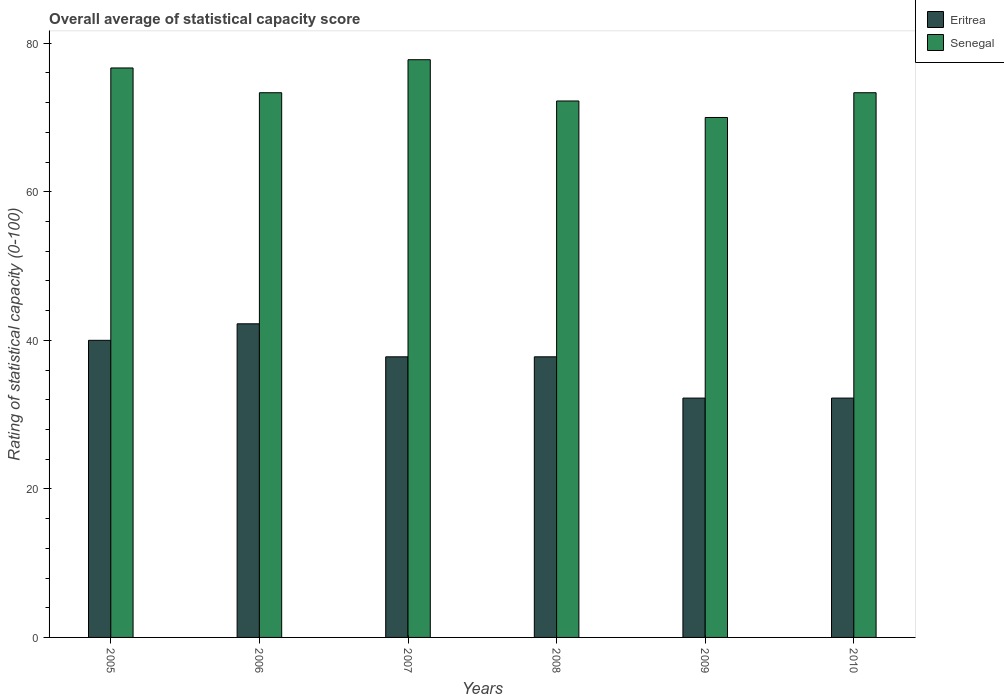How many different coloured bars are there?
Keep it short and to the point. 2. Are the number of bars per tick equal to the number of legend labels?
Give a very brief answer. Yes. How many bars are there on the 4th tick from the right?
Your answer should be very brief. 2. What is the label of the 5th group of bars from the left?
Offer a terse response. 2009. In how many cases, is the number of bars for a given year not equal to the number of legend labels?
Offer a terse response. 0. What is the rating of statistical capacity in Eritrea in 2009?
Offer a terse response. 32.22. Across all years, what is the maximum rating of statistical capacity in Eritrea?
Offer a terse response. 42.22. Across all years, what is the minimum rating of statistical capacity in Eritrea?
Ensure brevity in your answer.  32.22. In which year was the rating of statistical capacity in Senegal minimum?
Offer a terse response. 2009. What is the total rating of statistical capacity in Eritrea in the graph?
Make the answer very short. 222.22. What is the difference between the rating of statistical capacity in Senegal in 2008 and that in 2009?
Provide a short and direct response. 2.22. What is the difference between the rating of statistical capacity in Senegal in 2007 and the rating of statistical capacity in Eritrea in 2010?
Provide a succinct answer. 45.56. What is the average rating of statistical capacity in Eritrea per year?
Your response must be concise. 37.04. In the year 2009, what is the difference between the rating of statistical capacity in Senegal and rating of statistical capacity in Eritrea?
Keep it short and to the point. 37.78. In how many years, is the rating of statistical capacity in Eritrea greater than 4?
Your response must be concise. 6. What is the ratio of the rating of statistical capacity in Senegal in 2008 to that in 2009?
Keep it short and to the point. 1.03. What is the difference between the highest and the second highest rating of statistical capacity in Senegal?
Your answer should be compact. 1.11. What is the difference between the highest and the lowest rating of statistical capacity in Eritrea?
Your answer should be very brief. 10. Is the sum of the rating of statistical capacity in Eritrea in 2008 and 2009 greater than the maximum rating of statistical capacity in Senegal across all years?
Provide a short and direct response. No. What does the 1st bar from the left in 2010 represents?
Give a very brief answer. Eritrea. What does the 2nd bar from the right in 2008 represents?
Offer a terse response. Eritrea. How many bars are there?
Your answer should be very brief. 12. How many years are there in the graph?
Keep it short and to the point. 6. Are the values on the major ticks of Y-axis written in scientific E-notation?
Your response must be concise. No. Does the graph contain any zero values?
Your answer should be compact. No. Does the graph contain grids?
Your answer should be very brief. No. What is the title of the graph?
Provide a succinct answer. Overall average of statistical capacity score. What is the label or title of the Y-axis?
Ensure brevity in your answer.  Rating of statistical capacity (0-100). What is the Rating of statistical capacity (0-100) of Eritrea in 2005?
Offer a very short reply. 40. What is the Rating of statistical capacity (0-100) of Senegal in 2005?
Give a very brief answer. 76.67. What is the Rating of statistical capacity (0-100) in Eritrea in 2006?
Give a very brief answer. 42.22. What is the Rating of statistical capacity (0-100) in Senegal in 2006?
Your answer should be compact. 73.33. What is the Rating of statistical capacity (0-100) in Eritrea in 2007?
Give a very brief answer. 37.78. What is the Rating of statistical capacity (0-100) in Senegal in 2007?
Provide a short and direct response. 77.78. What is the Rating of statistical capacity (0-100) in Eritrea in 2008?
Give a very brief answer. 37.78. What is the Rating of statistical capacity (0-100) of Senegal in 2008?
Give a very brief answer. 72.22. What is the Rating of statistical capacity (0-100) in Eritrea in 2009?
Give a very brief answer. 32.22. What is the Rating of statistical capacity (0-100) of Eritrea in 2010?
Provide a short and direct response. 32.22. What is the Rating of statistical capacity (0-100) in Senegal in 2010?
Offer a very short reply. 73.33. Across all years, what is the maximum Rating of statistical capacity (0-100) of Eritrea?
Ensure brevity in your answer.  42.22. Across all years, what is the maximum Rating of statistical capacity (0-100) in Senegal?
Provide a short and direct response. 77.78. Across all years, what is the minimum Rating of statistical capacity (0-100) of Eritrea?
Give a very brief answer. 32.22. What is the total Rating of statistical capacity (0-100) of Eritrea in the graph?
Ensure brevity in your answer.  222.22. What is the total Rating of statistical capacity (0-100) of Senegal in the graph?
Provide a succinct answer. 443.33. What is the difference between the Rating of statistical capacity (0-100) in Eritrea in 2005 and that in 2006?
Provide a succinct answer. -2.22. What is the difference between the Rating of statistical capacity (0-100) in Eritrea in 2005 and that in 2007?
Your answer should be compact. 2.22. What is the difference between the Rating of statistical capacity (0-100) of Senegal in 2005 and that in 2007?
Ensure brevity in your answer.  -1.11. What is the difference between the Rating of statistical capacity (0-100) in Eritrea in 2005 and that in 2008?
Give a very brief answer. 2.22. What is the difference between the Rating of statistical capacity (0-100) in Senegal in 2005 and that in 2008?
Offer a very short reply. 4.44. What is the difference between the Rating of statistical capacity (0-100) of Eritrea in 2005 and that in 2009?
Give a very brief answer. 7.78. What is the difference between the Rating of statistical capacity (0-100) of Senegal in 2005 and that in 2009?
Make the answer very short. 6.67. What is the difference between the Rating of statistical capacity (0-100) of Eritrea in 2005 and that in 2010?
Provide a short and direct response. 7.78. What is the difference between the Rating of statistical capacity (0-100) of Senegal in 2005 and that in 2010?
Offer a terse response. 3.33. What is the difference between the Rating of statistical capacity (0-100) in Eritrea in 2006 and that in 2007?
Ensure brevity in your answer.  4.44. What is the difference between the Rating of statistical capacity (0-100) in Senegal in 2006 and that in 2007?
Keep it short and to the point. -4.44. What is the difference between the Rating of statistical capacity (0-100) of Eritrea in 2006 and that in 2008?
Provide a short and direct response. 4.44. What is the difference between the Rating of statistical capacity (0-100) in Senegal in 2006 and that in 2008?
Provide a short and direct response. 1.11. What is the difference between the Rating of statistical capacity (0-100) in Eritrea in 2006 and that in 2010?
Provide a short and direct response. 10. What is the difference between the Rating of statistical capacity (0-100) in Senegal in 2007 and that in 2008?
Your answer should be very brief. 5.56. What is the difference between the Rating of statistical capacity (0-100) in Eritrea in 2007 and that in 2009?
Give a very brief answer. 5.56. What is the difference between the Rating of statistical capacity (0-100) of Senegal in 2007 and that in 2009?
Offer a terse response. 7.78. What is the difference between the Rating of statistical capacity (0-100) of Eritrea in 2007 and that in 2010?
Give a very brief answer. 5.56. What is the difference between the Rating of statistical capacity (0-100) of Senegal in 2007 and that in 2010?
Provide a succinct answer. 4.44. What is the difference between the Rating of statistical capacity (0-100) in Eritrea in 2008 and that in 2009?
Keep it short and to the point. 5.56. What is the difference between the Rating of statistical capacity (0-100) of Senegal in 2008 and that in 2009?
Give a very brief answer. 2.22. What is the difference between the Rating of statistical capacity (0-100) of Eritrea in 2008 and that in 2010?
Offer a very short reply. 5.56. What is the difference between the Rating of statistical capacity (0-100) in Senegal in 2008 and that in 2010?
Your response must be concise. -1.11. What is the difference between the Rating of statistical capacity (0-100) in Eritrea in 2005 and the Rating of statistical capacity (0-100) in Senegal in 2006?
Your response must be concise. -33.33. What is the difference between the Rating of statistical capacity (0-100) in Eritrea in 2005 and the Rating of statistical capacity (0-100) in Senegal in 2007?
Offer a very short reply. -37.78. What is the difference between the Rating of statistical capacity (0-100) of Eritrea in 2005 and the Rating of statistical capacity (0-100) of Senegal in 2008?
Ensure brevity in your answer.  -32.22. What is the difference between the Rating of statistical capacity (0-100) in Eritrea in 2005 and the Rating of statistical capacity (0-100) in Senegal in 2009?
Keep it short and to the point. -30. What is the difference between the Rating of statistical capacity (0-100) in Eritrea in 2005 and the Rating of statistical capacity (0-100) in Senegal in 2010?
Your response must be concise. -33.33. What is the difference between the Rating of statistical capacity (0-100) of Eritrea in 2006 and the Rating of statistical capacity (0-100) of Senegal in 2007?
Your answer should be very brief. -35.56. What is the difference between the Rating of statistical capacity (0-100) of Eritrea in 2006 and the Rating of statistical capacity (0-100) of Senegal in 2008?
Give a very brief answer. -30. What is the difference between the Rating of statistical capacity (0-100) of Eritrea in 2006 and the Rating of statistical capacity (0-100) of Senegal in 2009?
Ensure brevity in your answer.  -27.78. What is the difference between the Rating of statistical capacity (0-100) of Eritrea in 2006 and the Rating of statistical capacity (0-100) of Senegal in 2010?
Your response must be concise. -31.11. What is the difference between the Rating of statistical capacity (0-100) in Eritrea in 2007 and the Rating of statistical capacity (0-100) in Senegal in 2008?
Provide a succinct answer. -34.44. What is the difference between the Rating of statistical capacity (0-100) in Eritrea in 2007 and the Rating of statistical capacity (0-100) in Senegal in 2009?
Your answer should be very brief. -32.22. What is the difference between the Rating of statistical capacity (0-100) in Eritrea in 2007 and the Rating of statistical capacity (0-100) in Senegal in 2010?
Your answer should be compact. -35.56. What is the difference between the Rating of statistical capacity (0-100) in Eritrea in 2008 and the Rating of statistical capacity (0-100) in Senegal in 2009?
Offer a terse response. -32.22. What is the difference between the Rating of statistical capacity (0-100) of Eritrea in 2008 and the Rating of statistical capacity (0-100) of Senegal in 2010?
Ensure brevity in your answer.  -35.56. What is the difference between the Rating of statistical capacity (0-100) in Eritrea in 2009 and the Rating of statistical capacity (0-100) in Senegal in 2010?
Ensure brevity in your answer.  -41.11. What is the average Rating of statistical capacity (0-100) in Eritrea per year?
Offer a very short reply. 37.04. What is the average Rating of statistical capacity (0-100) in Senegal per year?
Keep it short and to the point. 73.89. In the year 2005, what is the difference between the Rating of statistical capacity (0-100) in Eritrea and Rating of statistical capacity (0-100) in Senegal?
Provide a short and direct response. -36.67. In the year 2006, what is the difference between the Rating of statistical capacity (0-100) of Eritrea and Rating of statistical capacity (0-100) of Senegal?
Offer a terse response. -31.11. In the year 2007, what is the difference between the Rating of statistical capacity (0-100) in Eritrea and Rating of statistical capacity (0-100) in Senegal?
Make the answer very short. -40. In the year 2008, what is the difference between the Rating of statistical capacity (0-100) of Eritrea and Rating of statistical capacity (0-100) of Senegal?
Make the answer very short. -34.44. In the year 2009, what is the difference between the Rating of statistical capacity (0-100) of Eritrea and Rating of statistical capacity (0-100) of Senegal?
Your response must be concise. -37.78. In the year 2010, what is the difference between the Rating of statistical capacity (0-100) in Eritrea and Rating of statistical capacity (0-100) in Senegal?
Keep it short and to the point. -41.11. What is the ratio of the Rating of statistical capacity (0-100) in Senegal in 2005 to that in 2006?
Your answer should be compact. 1.05. What is the ratio of the Rating of statistical capacity (0-100) of Eritrea in 2005 to that in 2007?
Ensure brevity in your answer.  1.06. What is the ratio of the Rating of statistical capacity (0-100) of Senegal in 2005 to that in 2007?
Your response must be concise. 0.99. What is the ratio of the Rating of statistical capacity (0-100) of Eritrea in 2005 to that in 2008?
Provide a succinct answer. 1.06. What is the ratio of the Rating of statistical capacity (0-100) of Senegal in 2005 to that in 2008?
Provide a short and direct response. 1.06. What is the ratio of the Rating of statistical capacity (0-100) in Eritrea in 2005 to that in 2009?
Keep it short and to the point. 1.24. What is the ratio of the Rating of statistical capacity (0-100) of Senegal in 2005 to that in 2009?
Offer a terse response. 1.1. What is the ratio of the Rating of statistical capacity (0-100) of Eritrea in 2005 to that in 2010?
Make the answer very short. 1.24. What is the ratio of the Rating of statistical capacity (0-100) of Senegal in 2005 to that in 2010?
Offer a very short reply. 1.05. What is the ratio of the Rating of statistical capacity (0-100) in Eritrea in 2006 to that in 2007?
Offer a terse response. 1.12. What is the ratio of the Rating of statistical capacity (0-100) of Senegal in 2006 to that in 2007?
Provide a short and direct response. 0.94. What is the ratio of the Rating of statistical capacity (0-100) of Eritrea in 2006 to that in 2008?
Your answer should be very brief. 1.12. What is the ratio of the Rating of statistical capacity (0-100) in Senegal in 2006 to that in 2008?
Provide a short and direct response. 1.02. What is the ratio of the Rating of statistical capacity (0-100) in Eritrea in 2006 to that in 2009?
Your answer should be compact. 1.31. What is the ratio of the Rating of statistical capacity (0-100) of Senegal in 2006 to that in 2009?
Offer a terse response. 1.05. What is the ratio of the Rating of statistical capacity (0-100) in Eritrea in 2006 to that in 2010?
Your response must be concise. 1.31. What is the ratio of the Rating of statistical capacity (0-100) of Eritrea in 2007 to that in 2008?
Your answer should be very brief. 1. What is the ratio of the Rating of statistical capacity (0-100) of Eritrea in 2007 to that in 2009?
Ensure brevity in your answer.  1.17. What is the ratio of the Rating of statistical capacity (0-100) of Senegal in 2007 to that in 2009?
Your answer should be compact. 1.11. What is the ratio of the Rating of statistical capacity (0-100) of Eritrea in 2007 to that in 2010?
Offer a very short reply. 1.17. What is the ratio of the Rating of statistical capacity (0-100) of Senegal in 2007 to that in 2010?
Offer a terse response. 1.06. What is the ratio of the Rating of statistical capacity (0-100) of Eritrea in 2008 to that in 2009?
Offer a very short reply. 1.17. What is the ratio of the Rating of statistical capacity (0-100) in Senegal in 2008 to that in 2009?
Your response must be concise. 1.03. What is the ratio of the Rating of statistical capacity (0-100) of Eritrea in 2008 to that in 2010?
Give a very brief answer. 1.17. What is the ratio of the Rating of statistical capacity (0-100) in Senegal in 2008 to that in 2010?
Offer a very short reply. 0.98. What is the ratio of the Rating of statistical capacity (0-100) in Eritrea in 2009 to that in 2010?
Your answer should be very brief. 1. What is the ratio of the Rating of statistical capacity (0-100) in Senegal in 2009 to that in 2010?
Provide a succinct answer. 0.95. What is the difference between the highest and the second highest Rating of statistical capacity (0-100) of Eritrea?
Your answer should be compact. 2.22. What is the difference between the highest and the second highest Rating of statistical capacity (0-100) in Senegal?
Provide a succinct answer. 1.11. What is the difference between the highest and the lowest Rating of statistical capacity (0-100) in Senegal?
Give a very brief answer. 7.78. 